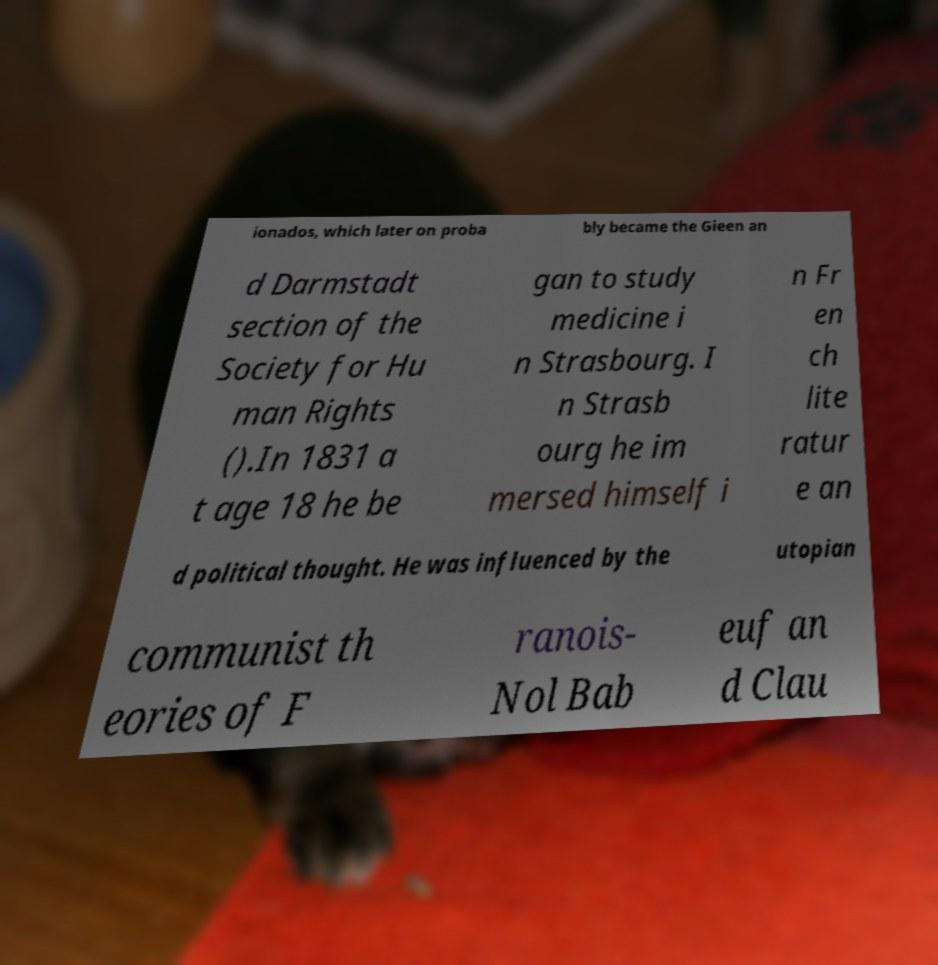For documentation purposes, I need the text within this image transcribed. Could you provide that? ionados, which later on proba bly became the Gieen an d Darmstadt section of the Society for Hu man Rights ().In 1831 a t age 18 he be gan to study medicine i n Strasbourg. I n Strasb ourg he im mersed himself i n Fr en ch lite ratur e an d political thought. He was influenced by the utopian communist th eories of F ranois- Nol Bab euf an d Clau 